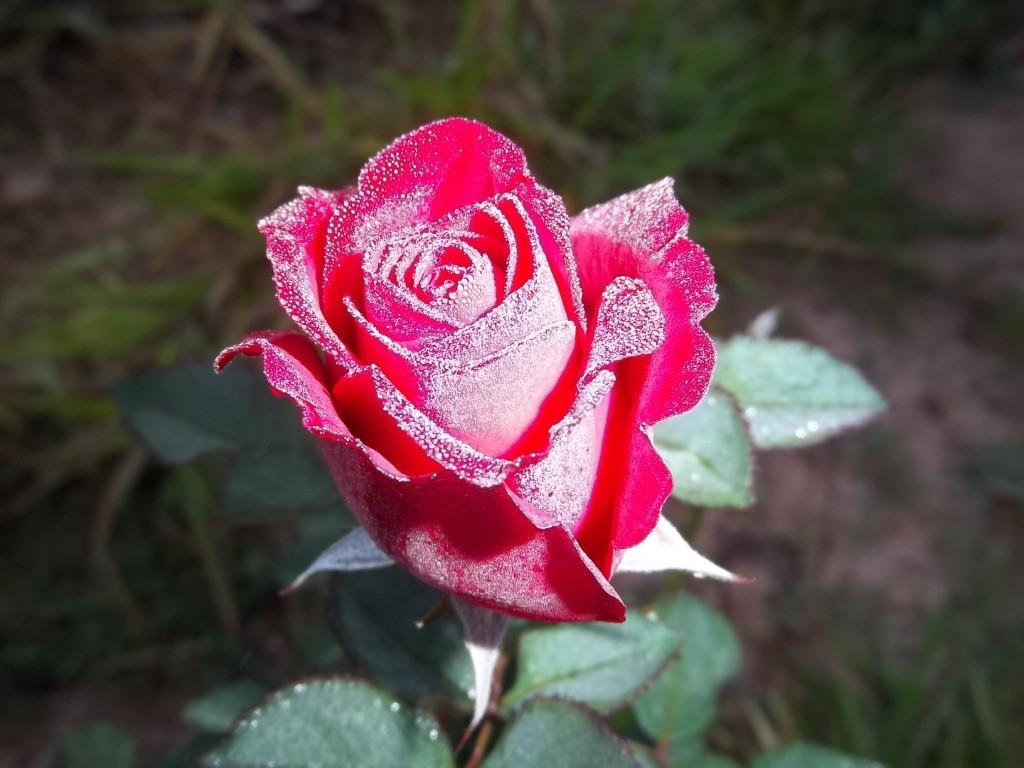What type of flower is in the image? There is a red-colored rose in the image. What is the rose placed on? The rose is on a plant with leaves. What can be seen in the background of the image? There is a grassland visible in the background of the image. What type of voice can be heard coming from the rose in the image? There is no voice coming from the rose in the image, as it is a flower and does not have the ability to produce sound. 